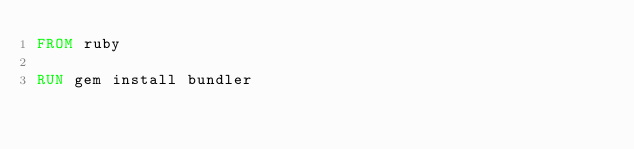<code> <loc_0><loc_0><loc_500><loc_500><_Dockerfile_>FROM ruby

RUN gem install bundler
</code> 